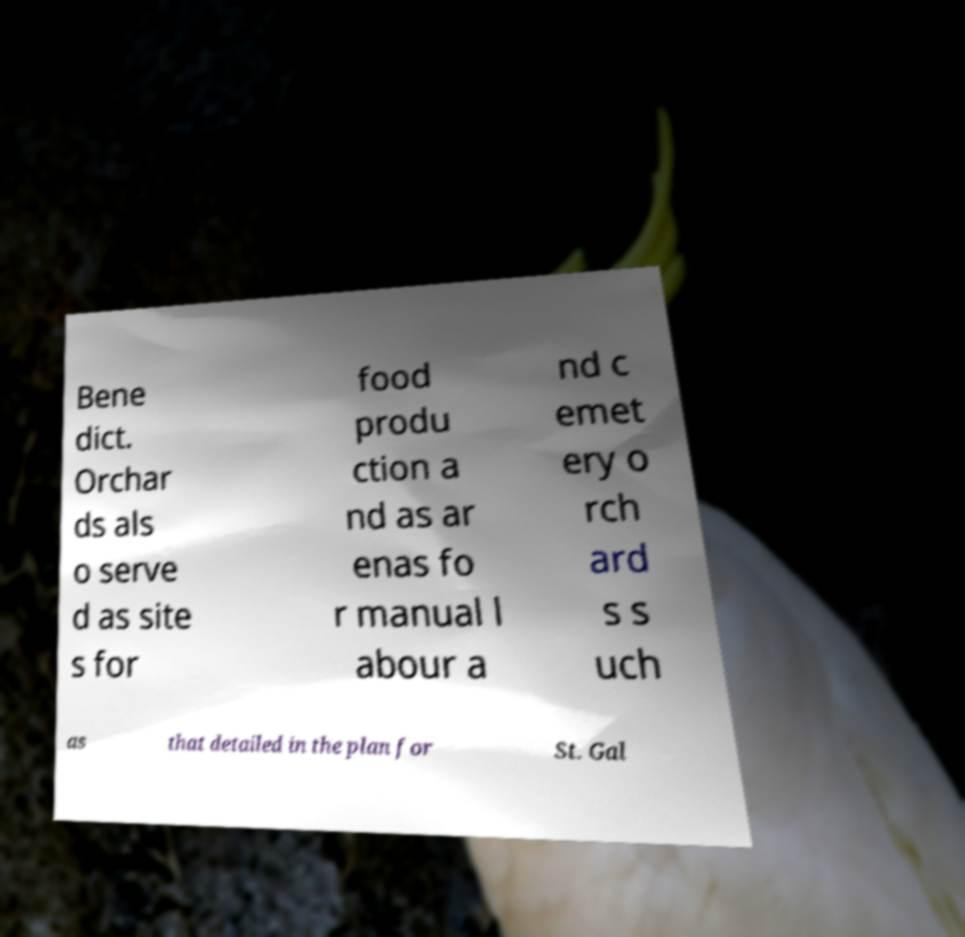Could you extract and type out the text from this image? Bene dict. Orchar ds als o serve d as site s for food produ ction a nd as ar enas fo r manual l abour a nd c emet ery o rch ard s s uch as that detailed in the plan for St. Gal 